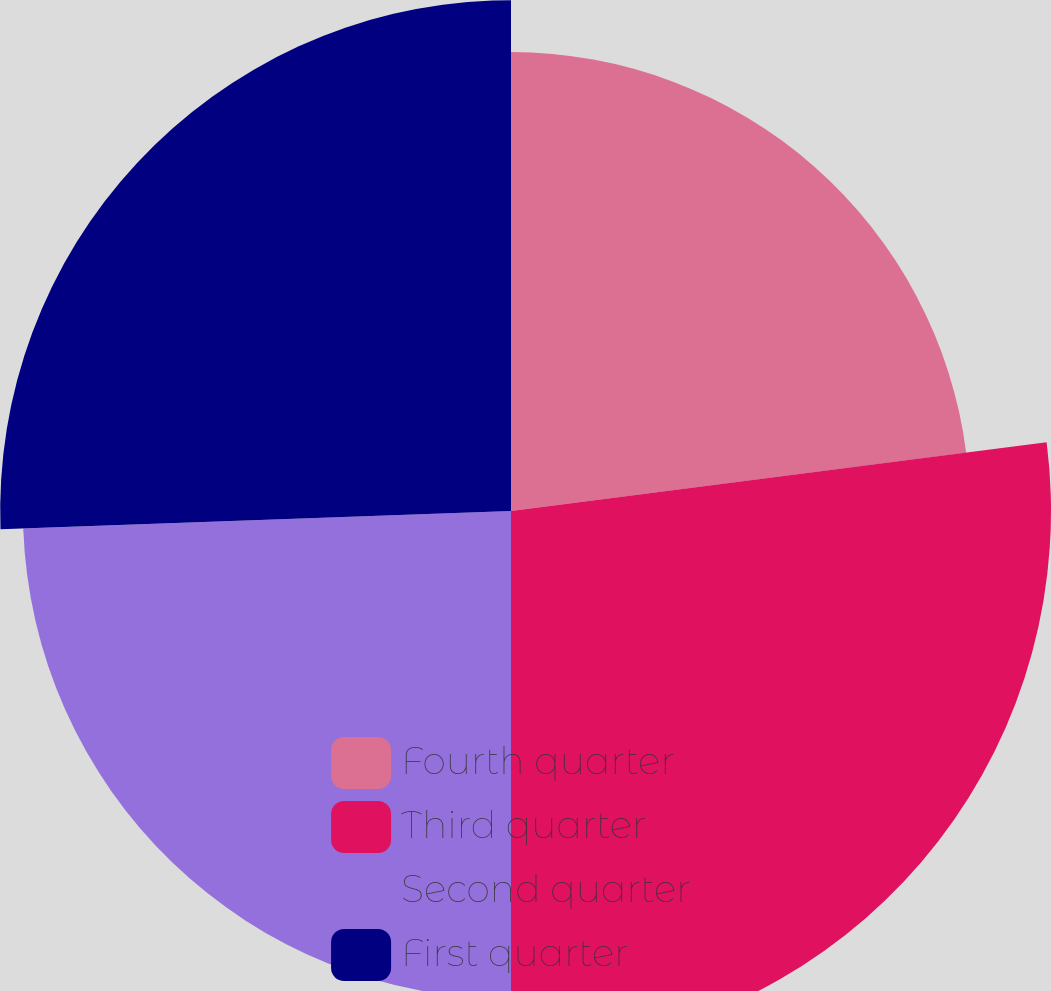<chart> <loc_0><loc_0><loc_500><loc_500><pie_chart><fcel>Fourth quarter<fcel>Third quarter<fcel>Second quarter<fcel>First quarter<nl><fcel>22.97%<fcel>27.03%<fcel>24.43%<fcel>25.57%<nl></chart> 